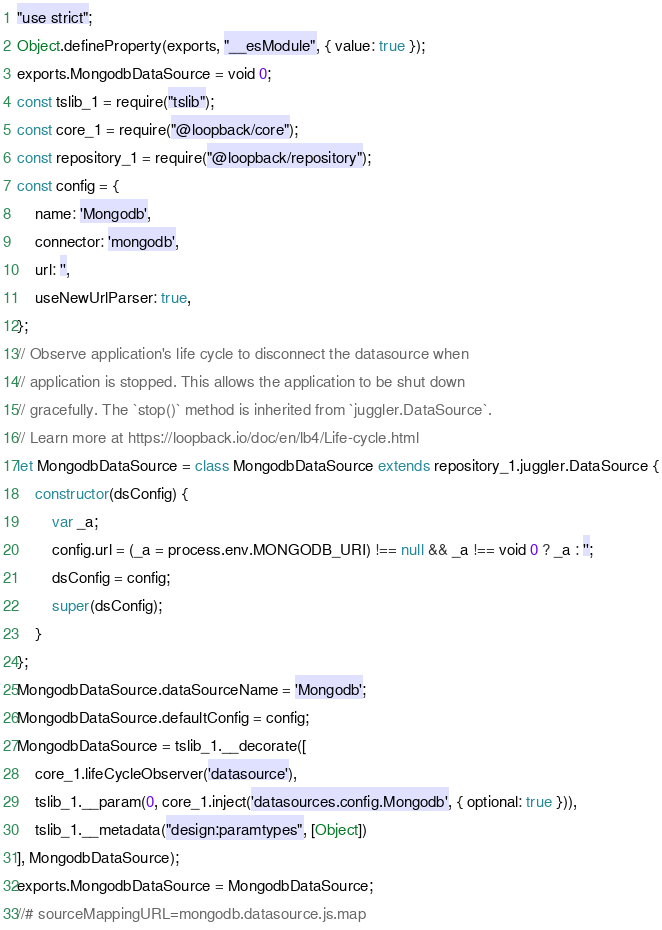Convert code to text. <code><loc_0><loc_0><loc_500><loc_500><_JavaScript_>"use strict";
Object.defineProperty(exports, "__esModule", { value: true });
exports.MongodbDataSource = void 0;
const tslib_1 = require("tslib");
const core_1 = require("@loopback/core");
const repository_1 = require("@loopback/repository");
const config = {
    name: 'Mongodb',
    connector: 'mongodb',
    url: '',
    useNewUrlParser: true,
};
// Observe application's life cycle to disconnect the datasource when
// application is stopped. This allows the application to be shut down
// gracefully. The `stop()` method is inherited from `juggler.DataSource`.
// Learn more at https://loopback.io/doc/en/lb4/Life-cycle.html
let MongodbDataSource = class MongodbDataSource extends repository_1.juggler.DataSource {
    constructor(dsConfig) {
        var _a;
        config.url = (_a = process.env.MONGODB_URI) !== null && _a !== void 0 ? _a : '';
        dsConfig = config;
        super(dsConfig);
    }
};
MongodbDataSource.dataSourceName = 'Mongodb';
MongodbDataSource.defaultConfig = config;
MongodbDataSource = tslib_1.__decorate([
    core_1.lifeCycleObserver('datasource'),
    tslib_1.__param(0, core_1.inject('datasources.config.Mongodb', { optional: true })),
    tslib_1.__metadata("design:paramtypes", [Object])
], MongodbDataSource);
exports.MongodbDataSource = MongodbDataSource;
//# sourceMappingURL=mongodb.datasource.js.map</code> 